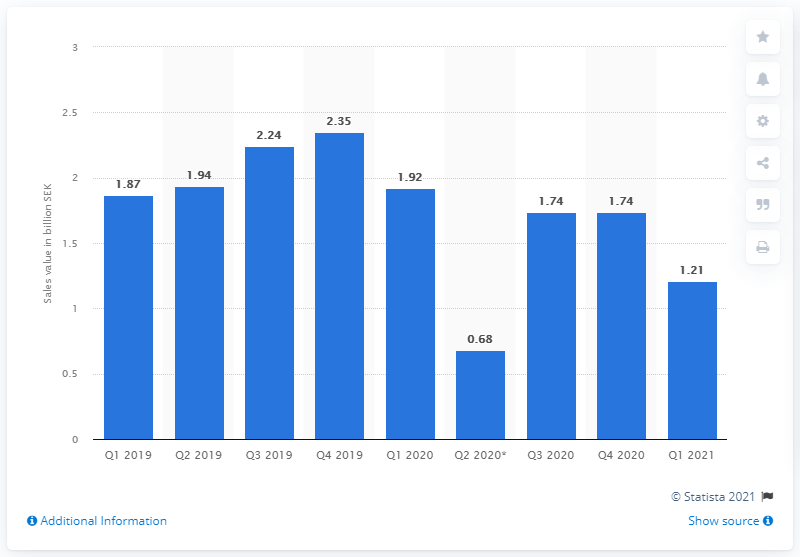Outline some significant characteristics in this image. H&M's net sales in Italy for the second quarter of 2020 were 0.68 million euros. In the first quarter of 2021, net sales amounted to 121 Swedish krona. 